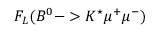<formula> <loc_0><loc_0><loc_500><loc_500>F _ { L } ( B ^ { 0 } - > K ^ { ^ { * } } \mu ^ { + } \mu ^ { - } )</formula> 